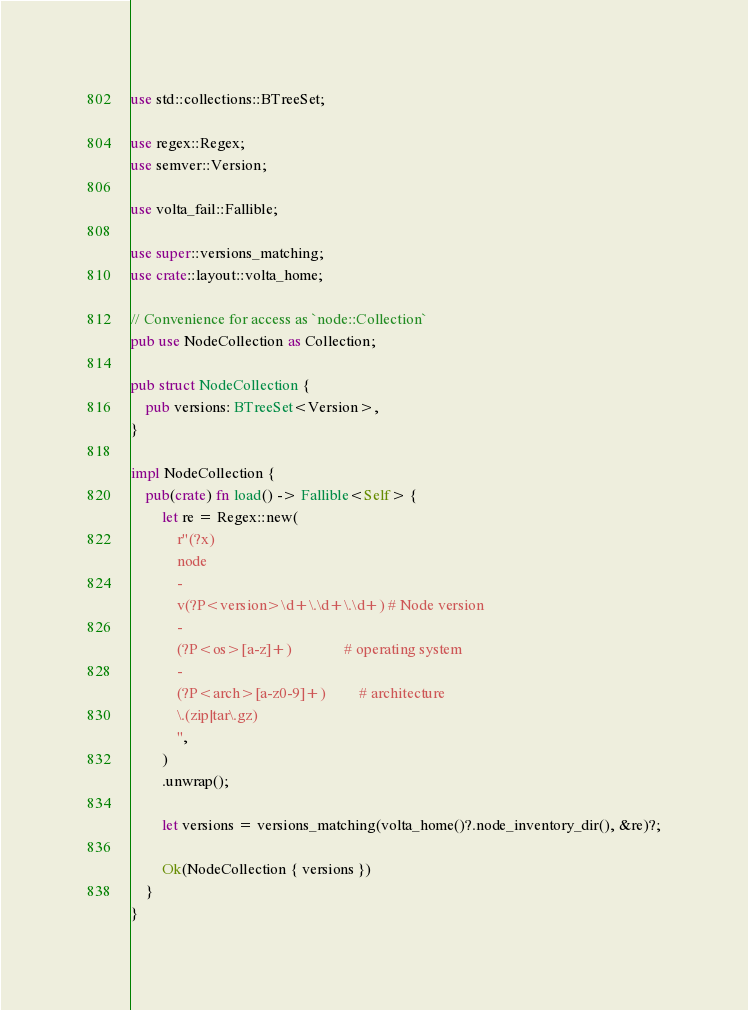<code> <loc_0><loc_0><loc_500><loc_500><_Rust_>use std::collections::BTreeSet;

use regex::Regex;
use semver::Version;

use volta_fail::Fallible;

use super::versions_matching;
use crate::layout::volta_home;

// Convenience for access as `node::Collection`
pub use NodeCollection as Collection;

pub struct NodeCollection {
    pub versions: BTreeSet<Version>,
}

impl NodeCollection {
    pub(crate) fn load() -> Fallible<Self> {
        let re = Regex::new(
            r"(?x)
            node
            -
            v(?P<version>\d+\.\d+\.\d+) # Node version
            -
            (?P<os>[a-z]+)              # operating system
            -
            (?P<arch>[a-z0-9]+)         # architecture
            \.(zip|tar\.gz)
            ",
        )
        .unwrap();

        let versions = versions_matching(volta_home()?.node_inventory_dir(), &re)?;

        Ok(NodeCollection { versions })
    }
}
</code> 